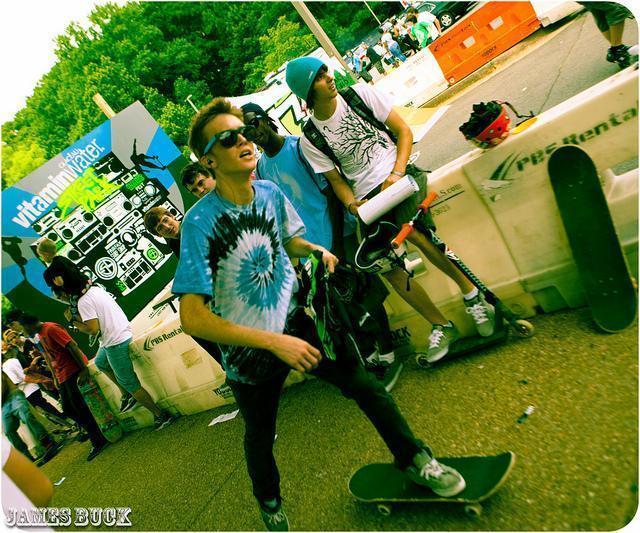What type of event is happening here?
Indicate the correct response and explain using: 'Answer: answer
Rationale: rationale.'
Options: Rodeo, dog show, movie, skateboard expo. Answer: skateboard expo.
Rationale: There are ramps and advertisements 